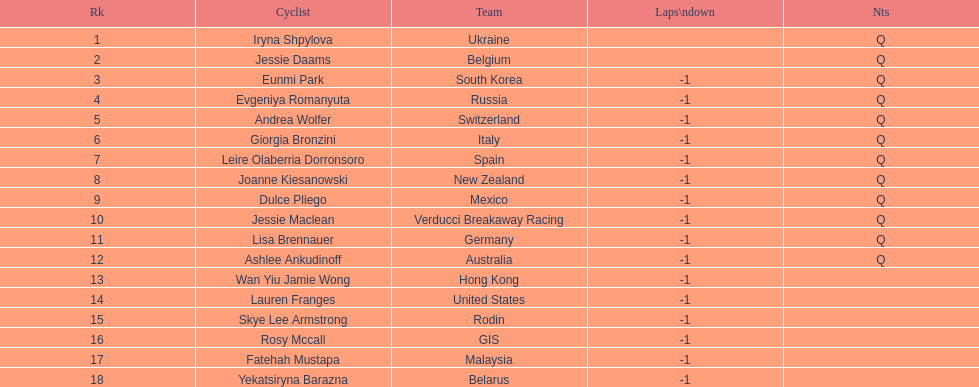Who competed in the race? Iryna Shpylova, Jessie Daams, Eunmi Park, Evgeniya Romanyuta, Andrea Wolfer, Giorgia Bronzini, Leire Olaberria Dorronsoro, Joanne Kiesanowski, Dulce Pliego, Jessie Maclean, Lisa Brennauer, Ashlee Ankudinoff, Wan Yiu Jamie Wong, Lauren Franges, Skye Lee Armstrong, Rosy Mccall, Fatehah Mustapa, Yekatsiryna Barazna. Who ranked highest in the race? Iryna Shpylova. 